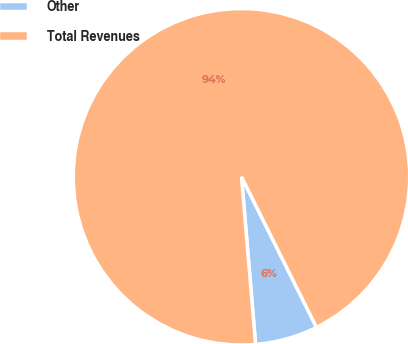<chart> <loc_0><loc_0><loc_500><loc_500><pie_chart><fcel>Other<fcel>Total Revenues<nl><fcel>6.02%<fcel>93.98%<nl></chart> 